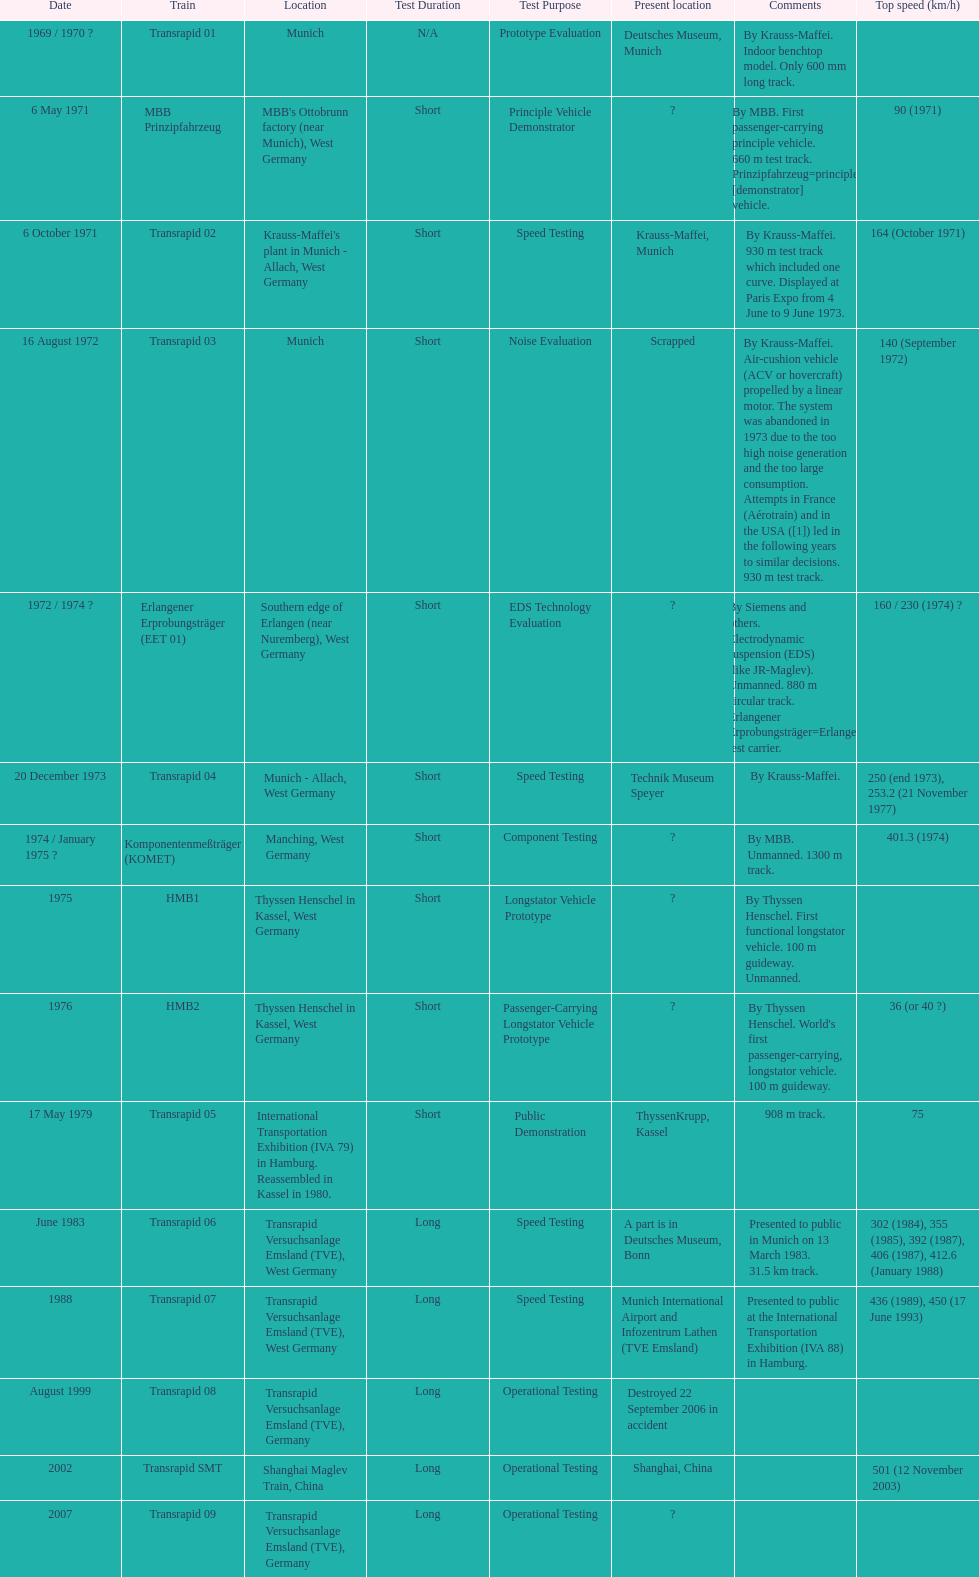Could you parse the entire table as a dict? {'header': ['Date', 'Train', 'Location', 'Test Duration', 'Test Purpose', 'Present location', 'Comments', 'Top speed (km/h)'], 'rows': [['1969 / 1970\xa0?', 'Transrapid 01', 'Munich', 'N/A', 'Prototype Evaluation', 'Deutsches Museum, Munich', 'By Krauss-Maffei. Indoor benchtop model. Only 600\xa0mm long track.', ''], ['6 May 1971', 'MBB Prinzipfahrzeug', "MBB's Ottobrunn factory (near Munich), West Germany", 'Short', 'Principle Vehicle Demonstrator', '?', 'By MBB. First passenger-carrying principle vehicle. 660 m test track. Prinzipfahrzeug=principle [demonstrator] vehicle.', '90 (1971)'], ['6 October 1971', 'Transrapid 02', "Krauss-Maffei's plant in Munich - Allach, West Germany", 'Short', 'Speed Testing', 'Krauss-Maffei, Munich', 'By Krauss-Maffei. 930 m test track which included one curve. Displayed at Paris Expo from 4 June to 9 June 1973.', '164 (October 1971)'], ['16 August 1972', 'Transrapid 03', 'Munich', 'Short', 'Noise Evaluation', 'Scrapped', 'By Krauss-Maffei. Air-cushion vehicle (ACV or hovercraft) propelled by a linear motor. The system was abandoned in 1973 due to the too high noise generation and the too large consumption. Attempts in France (Aérotrain) and in the USA ([1]) led in the following years to similar decisions. 930 m test track.', '140 (September 1972)'], ['1972 / 1974\xa0?', 'Erlangener Erprobungsträger (EET 01)', 'Southern edge of Erlangen (near Nuremberg), West Germany', 'Short', 'EDS Technology Evaluation', '?', 'By Siemens and others. Electrodynamic suspension (EDS) (like JR-Maglev). Unmanned. 880 m circular track. Erlangener Erprobungsträger=Erlangen test carrier.', '160 / 230 (1974)\xa0?'], ['20 December 1973', 'Transrapid 04', 'Munich - Allach, West Germany', 'Short', 'Speed Testing', 'Technik Museum Speyer', 'By Krauss-Maffei.', '250 (end 1973), 253.2 (21 November 1977)'], ['1974 / January 1975\xa0?', 'Komponentenmeßträger (KOMET)', 'Manching, West Germany', 'Short', 'Component Testing', '?', 'By MBB. Unmanned. 1300 m track.', '401.3 (1974)'], ['1975', 'HMB1', 'Thyssen Henschel in Kassel, West Germany', 'Short', 'Longstator Vehicle Prototype', '?', 'By Thyssen Henschel. First functional longstator vehicle. 100 m guideway. Unmanned.', ''], ['1976', 'HMB2', 'Thyssen Henschel in Kassel, West Germany', 'Short', 'Passenger-Carrying Longstator Vehicle Prototype', '?', "By Thyssen Henschel. World's first passenger-carrying, longstator vehicle. 100 m guideway.", '36 (or 40\xa0?)'], ['17 May 1979', 'Transrapid 05', 'International Transportation Exhibition (IVA 79) in Hamburg. Reassembled in Kassel in 1980.', 'Short', 'Public Demonstration', 'ThyssenKrupp, Kassel', '908 m track.', '75'], ['June 1983', 'Transrapid 06', 'Transrapid Versuchsanlage Emsland (TVE), West Germany', 'Long', 'Speed Testing', 'A part is in Deutsches Museum, Bonn', 'Presented to public in Munich on 13 March 1983. 31.5\xa0km track.', '302 (1984), 355 (1985), 392 (1987), 406 (1987), 412.6 (January 1988)'], ['1988', 'Transrapid 07', 'Transrapid Versuchsanlage Emsland (TVE), West Germany', 'Long', 'Speed Testing', 'Munich International Airport and Infozentrum Lathen (TVE Emsland)', 'Presented to public at the International Transportation Exhibition (IVA 88) in Hamburg.', '436 (1989), 450 (17 June 1993)'], ['August 1999', 'Transrapid 08', 'Transrapid Versuchsanlage Emsland (TVE), Germany', 'Long', 'Operational Testing', 'Destroyed 22 September 2006 in accident', '', ''], ['2002', 'Transrapid SMT', 'Shanghai Maglev Train, China', 'Long', 'Operational Testing', 'Shanghai, China', '', '501 (12 November 2003)'], ['2007', 'Transrapid 09', 'Transrapid Versuchsanlage Emsland (TVE), Germany', 'Long', 'Operational Testing', '?', '', '']]} How many trains listed have the same speed as the hmb2? 0. 